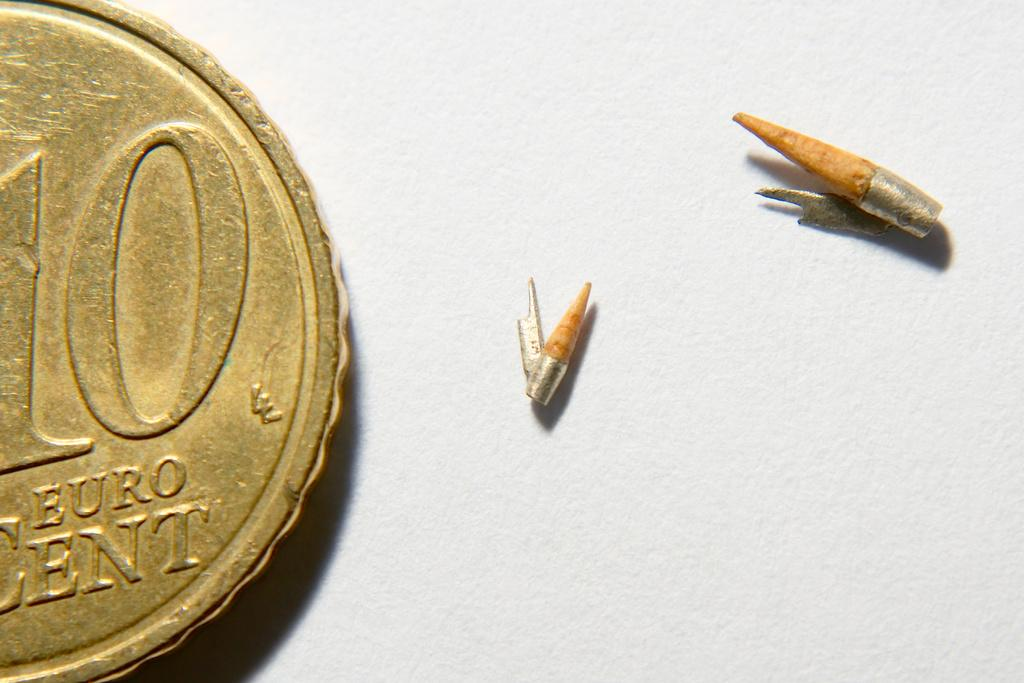<image>
Summarize the visual content of the image. A golden coin signify's it is a Euro 